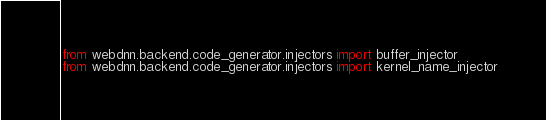<code> <loc_0><loc_0><loc_500><loc_500><_Python_>from webdnn.backend.code_generator.injectors import buffer_injector
from webdnn.backend.code_generator.injectors import kernel_name_injector
</code> 